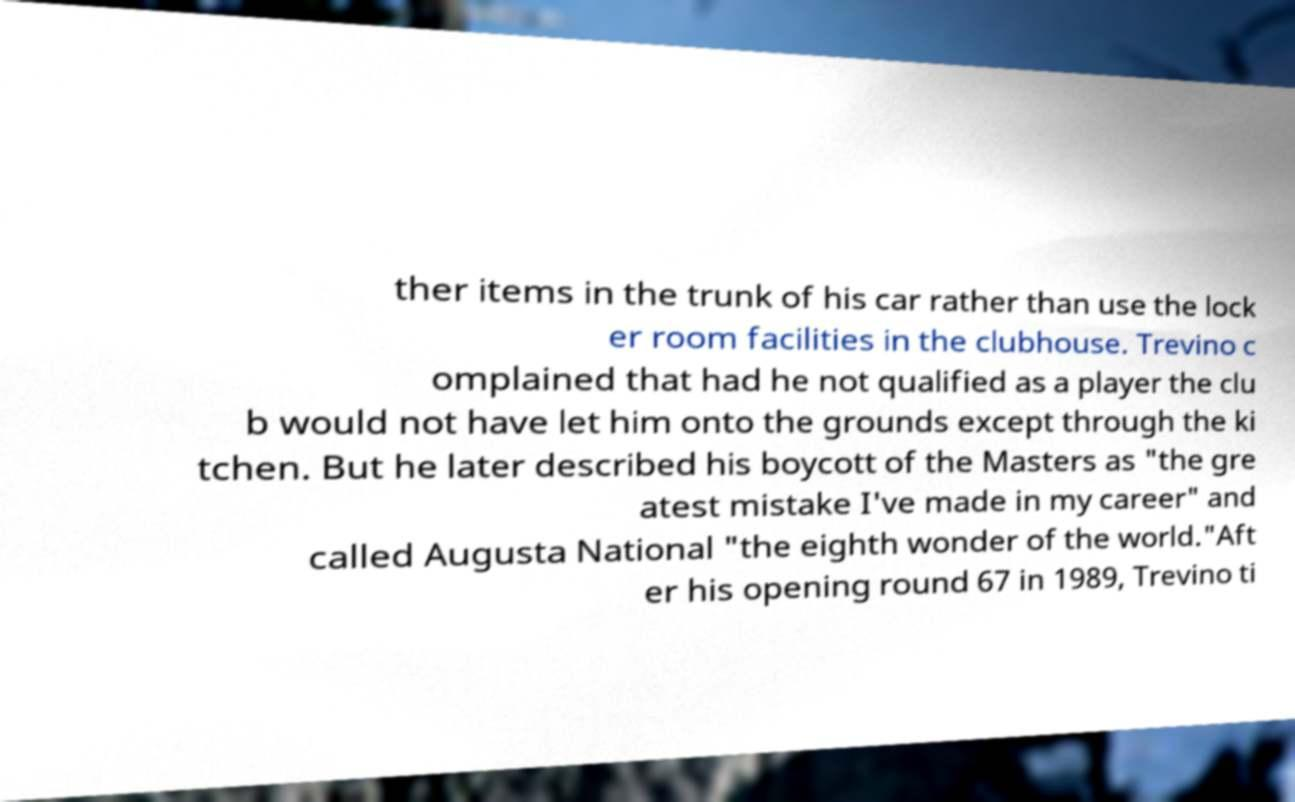For documentation purposes, I need the text within this image transcribed. Could you provide that? ther items in the trunk of his car rather than use the lock er room facilities in the clubhouse. Trevino c omplained that had he not qualified as a player the clu b would not have let him onto the grounds except through the ki tchen. But he later described his boycott of the Masters as "the gre atest mistake I've made in my career" and called Augusta National "the eighth wonder of the world."Aft er his opening round 67 in 1989, Trevino ti 